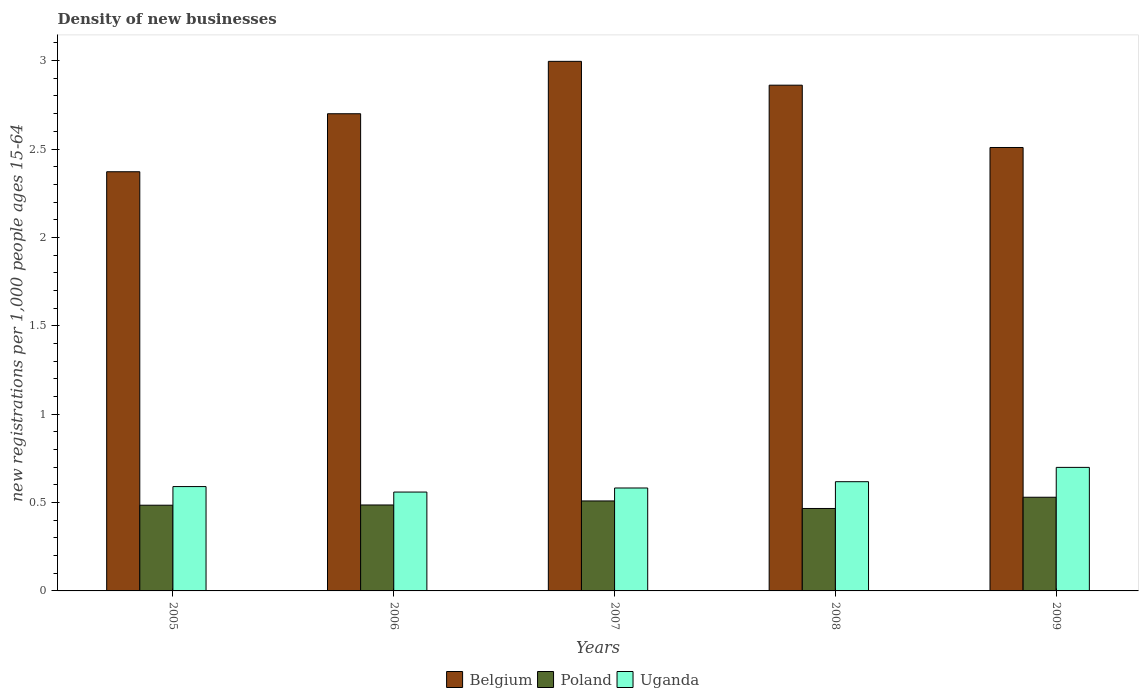How many different coloured bars are there?
Provide a short and direct response. 3. How many groups of bars are there?
Your answer should be compact. 5. What is the number of new registrations in Poland in 2006?
Make the answer very short. 0.49. Across all years, what is the maximum number of new registrations in Poland?
Offer a very short reply. 0.53. Across all years, what is the minimum number of new registrations in Poland?
Offer a terse response. 0.47. In which year was the number of new registrations in Uganda maximum?
Keep it short and to the point. 2009. What is the total number of new registrations in Uganda in the graph?
Provide a succinct answer. 3.05. What is the difference between the number of new registrations in Poland in 2005 and that in 2008?
Provide a short and direct response. 0.02. What is the difference between the number of new registrations in Poland in 2007 and the number of new registrations in Belgium in 2009?
Your answer should be very brief. -2. What is the average number of new registrations in Belgium per year?
Provide a succinct answer. 2.69. In the year 2006, what is the difference between the number of new registrations in Belgium and number of new registrations in Uganda?
Ensure brevity in your answer.  2.14. What is the ratio of the number of new registrations in Uganda in 2006 to that in 2007?
Provide a succinct answer. 0.96. Is the difference between the number of new registrations in Belgium in 2005 and 2006 greater than the difference between the number of new registrations in Uganda in 2005 and 2006?
Make the answer very short. No. What is the difference between the highest and the second highest number of new registrations in Poland?
Make the answer very short. 0.02. What is the difference between the highest and the lowest number of new registrations in Poland?
Make the answer very short. 0.06. Is the sum of the number of new registrations in Poland in 2005 and 2009 greater than the maximum number of new registrations in Uganda across all years?
Your answer should be compact. Yes. What does the 1st bar from the right in 2009 represents?
Your answer should be compact. Uganda. How many years are there in the graph?
Keep it short and to the point. 5. What is the difference between two consecutive major ticks on the Y-axis?
Your answer should be compact. 0.5. Are the values on the major ticks of Y-axis written in scientific E-notation?
Give a very brief answer. No. Does the graph contain any zero values?
Give a very brief answer. No. Does the graph contain grids?
Your response must be concise. No. Where does the legend appear in the graph?
Provide a short and direct response. Bottom center. How many legend labels are there?
Make the answer very short. 3. How are the legend labels stacked?
Your answer should be compact. Horizontal. What is the title of the graph?
Offer a terse response. Density of new businesses. What is the label or title of the X-axis?
Your answer should be compact. Years. What is the label or title of the Y-axis?
Your answer should be compact. New registrations per 1,0 people ages 15-64. What is the new registrations per 1,000 people ages 15-64 in Belgium in 2005?
Provide a short and direct response. 2.37. What is the new registrations per 1,000 people ages 15-64 of Poland in 2005?
Make the answer very short. 0.48. What is the new registrations per 1,000 people ages 15-64 of Uganda in 2005?
Your answer should be very brief. 0.59. What is the new registrations per 1,000 people ages 15-64 in Belgium in 2006?
Make the answer very short. 2.7. What is the new registrations per 1,000 people ages 15-64 of Poland in 2006?
Offer a very short reply. 0.49. What is the new registrations per 1,000 people ages 15-64 in Uganda in 2006?
Ensure brevity in your answer.  0.56. What is the new registrations per 1,000 people ages 15-64 in Belgium in 2007?
Provide a short and direct response. 3. What is the new registrations per 1,000 people ages 15-64 of Poland in 2007?
Provide a succinct answer. 0.51. What is the new registrations per 1,000 people ages 15-64 in Uganda in 2007?
Make the answer very short. 0.58. What is the new registrations per 1,000 people ages 15-64 in Belgium in 2008?
Offer a terse response. 2.86. What is the new registrations per 1,000 people ages 15-64 in Poland in 2008?
Keep it short and to the point. 0.47. What is the new registrations per 1,000 people ages 15-64 in Uganda in 2008?
Your response must be concise. 0.62. What is the new registrations per 1,000 people ages 15-64 of Belgium in 2009?
Your answer should be compact. 2.51. What is the new registrations per 1,000 people ages 15-64 in Poland in 2009?
Your answer should be compact. 0.53. What is the new registrations per 1,000 people ages 15-64 in Uganda in 2009?
Offer a terse response. 0.7. Across all years, what is the maximum new registrations per 1,000 people ages 15-64 of Belgium?
Provide a succinct answer. 3. Across all years, what is the maximum new registrations per 1,000 people ages 15-64 of Poland?
Give a very brief answer. 0.53. Across all years, what is the maximum new registrations per 1,000 people ages 15-64 in Uganda?
Make the answer very short. 0.7. Across all years, what is the minimum new registrations per 1,000 people ages 15-64 in Belgium?
Your answer should be compact. 2.37. Across all years, what is the minimum new registrations per 1,000 people ages 15-64 in Poland?
Ensure brevity in your answer.  0.47. Across all years, what is the minimum new registrations per 1,000 people ages 15-64 in Uganda?
Offer a terse response. 0.56. What is the total new registrations per 1,000 people ages 15-64 in Belgium in the graph?
Make the answer very short. 13.44. What is the total new registrations per 1,000 people ages 15-64 in Poland in the graph?
Offer a very short reply. 2.48. What is the total new registrations per 1,000 people ages 15-64 in Uganda in the graph?
Your answer should be very brief. 3.05. What is the difference between the new registrations per 1,000 people ages 15-64 of Belgium in 2005 and that in 2006?
Offer a very short reply. -0.33. What is the difference between the new registrations per 1,000 people ages 15-64 in Poland in 2005 and that in 2006?
Provide a short and direct response. -0. What is the difference between the new registrations per 1,000 people ages 15-64 in Uganda in 2005 and that in 2006?
Your answer should be very brief. 0.03. What is the difference between the new registrations per 1,000 people ages 15-64 in Belgium in 2005 and that in 2007?
Ensure brevity in your answer.  -0.62. What is the difference between the new registrations per 1,000 people ages 15-64 of Poland in 2005 and that in 2007?
Provide a succinct answer. -0.02. What is the difference between the new registrations per 1,000 people ages 15-64 in Uganda in 2005 and that in 2007?
Give a very brief answer. 0.01. What is the difference between the new registrations per 1,000 people ages 15-64 of Belgium in 2005 and that in 2008?
Offer a terse response. -0.49. What is the difference between the new registrations per 1,000 people ages 15-64 of Poland in 2005 and that in 2008?
Your answer should be very brief. 0.02. What is the difference between the new registrations per 1,000 people ages 15-64 in Uganda in 2005 and that in 2008?
Make the answer very short. -0.03. What is the difference between the new registrations per 1,000 people ages 15-64 of Belgium in 2005 and that in 2009?
Ensure brevity in your answer.  -0.14. What is the difference between the new registrations per 1,000 people ages 15-64 of Poland in 2005 and that in 2009?
Provide a short and direct response. -0.05. What is the difference between the new registrations per 1,000 people ages 15-64 of Uganda in 2005 and that in 2009?
Your answer should be compact. -0.11. What is the difference between the new registrations per 1,000 people ages 15-64 of Belgium in 2006 and that in 2007?
Offer a terse response. -0.3. What is the difference between the new registrations per 1,000 people ages 15-64 in Poland in 2006 and that in 2007?
Ensure brevity in your answer.  -0.02. What is the difference between the new registrations per 1,000 people ages 15-64 in Uganda in 2006 and that in 2007?
Make the answer very short. -0.02. What is the difference between the new registrations per 1,000 people ages 15-64 of Belgium in 2006 and that in 2008?
Your response must be concise. -0.16. What is the difference between the new registrations per 1,000 people ages 15-64 of Poland in 2006 and that in 2008?
Provide a succinct answer. 0.02. What is the difference between the new registrations per 1,000 people ages 15-64 in Uganda in 2006 and that in 2008?
Make the answer very short. -0.06. What is the difference between the new registrations per 1,000 people ages 15-64 in Belgium in 2006 and that in 2009?
Ensure brevity in your answer.  0.19. What is the difference between the new registrations per 1,000 people ages 15-64 of Poland in 2006 and that in 2009?
Ensure brevity in your answer.  -0.04. What is the difference between the new registrations per 1,000 people ages 15-64 in Uganda in 2006 and that in 2009?
Make the answer very short. -0.14. What is the difference between the new registrations per 1,000 people ages 15-64 in Belgium in 2007 and that in 2008?
Your answer should be very brief. 0.13. What is the difference between the new registrations per 1,000 people ages 15-64 in Poland in 2007 and that in 2008?
Your answer should be very brief. 0.04. What is the difference between the new registrations per 1,000 people ages 15-64 of Uganda in 2007 and that in 2008?
Your answer should be compact. -0.04. What is the difference between the new registrations per 1,000 people ages 15-64 in Belgium in 2007 and that in 2009?
Provide a short and direct response. 0.49. What is the difference between the new registrations per 1,000 people ages 15-64 of Poland in 2007 and that in 2009?
Your response must be concise. -0.02. What is the difference between the new registrations per 1,000 people ages 15-64 of Uganda in 2007 and that in 2009?
Provide a succinct answer. -0.12. What is the difference between the new registrations per 1,000 people ages 15-64 of Belgium in 2008 and that in 2009?
Provide a succinct answer. 0.35. What is the difference between the new registrations per 1,000 people ages 15-64 of Poland in 2008 and that in 2009?
Ensure brevity in your answer.  -0.06. What is the difference between the new registrations per 1,000 people ages 15-64 of Uganda in 2008 and that in 2009?
Your response must be concise. -0.08. What is the difference between the new registrations per 1,000 people ages 15-64 of Belgium in 2005 and the new registrations per 1,000 people ages 15-64 of Poland in 2006?
Your answer should be very brief. 1.89. What is the difference between the new registrations per 1,000 people ages 15-64 of Belgium in 2005 and the new registrations per 1,000 people ages 15-64 of Uganda in 2006?
Your answer should be compact. 1.81. What is the difference between the new registrations per 1,000 people ages 15-64 in Poland in 2005 and the new registrations per 1,000 people ages 15-64 in Uganda in 2006?
Provide a succinct answer. -0.07. What is the difference between the new registrations per 1,000 people ages 15-64 in Belgium in 2005 and the new registrations per 1,000 people ages 15-64 in Poland in 2007?
Provide a succinct answer. 1.86. What is the difference between the new registrations per 1,000 people ages 15-64 in Belgium in 2005 and the new registrations per 1,000 people ages 15-64 in Uganda in 2007?
Your answer should be very brief. 1.79. What is the difference between the new registrations per 1,000 people ages 15-64 of Poland in 2005 and the new registrations per 1,000 people ages 15-64 of Uganda in 2007?
Ensure brevity in your answer.  -0.1. What is the difference between the new registrations per 1,000 people ages 15-64 in Belgium in 2005 and the new registrations per 1,000 people ages 15-64 in Poland in 2008?
Your response must be concise. 1.91. What is the difference between the new registrations per 1,000 people ages 15-64 in Belgium in 2005 and the new registrations per 1,000 people ages 15-64 in Uganda in 2008?
Give a very brief answer. 1.75. What is the difference between the new registrations per 1,000 people ages 15-64 in Poland in 2005 and the new registrations per 1,000 people ages 15-64 in Uganda in 2008?
Your answer should be compact. -0.13. What is the difference between the new registrations per 1,000 people ages 15-64 in Belgium in 2005 and the new registrations per 1,000 people ages 15-64 in Poland in 2009?
Offer a very short reply. 1.84. What is the difference between the new registrations per 1,000 people ages 15-64 in Belgium in 2005 and the new registrations per 1,000 people ages 15-64 in Uganda in 2009?
Provide a short and direct response. 1.67. What is the difference between the new registrations per 1,000 people ages 15-64 in Poland in 2005 and the new registrations per 1,000 people ages 15-64 in Uganda in 2009?
Offer a very short reply. -0.21. What is the difference between the new registrations per 1,000 people ages 15-64 of Belgium in 2006 and the new registrations per 1,000 people ages 15-64 of Poland in 2007?
Your answer should be very brief. 2.19. What is the difference between the new registrations per 1,000 people ages 15-64 in Belgium in 2006 and the new registrations per 1,000 people ages 15-64 in Uganda in 2007?
Your response must be concise. 2.12. What is the difference between the new registrations per 1,000 people ages 15-64 of Poland in 2006 and the new registrations per 1,000 people ages 15-64 of Uganda in 2007?
Provide a short and direct response. -0.1. What is the difference between the new registrations per 1,000 people ages 15-64 of Belgium in 2006 and the new registrations per 1,000 people ages 15-64 of Poland in 2008?
Provide a succinct answer. 2.23. What is the difference between the new registrations per 1,000 people ages 15-64 of Belgium in 2006 and the new registrations per 1,000 people ages 15-64 of Uganda in 2008?
Offer a very short reply. 2.08. What is the difference between the new registrations per 1,000 people ages 15-64 in Poland in 2006 and the new registrations per 1,000 people ages 15-64 in Uganda in 2008?
Your response must be concise. -0.13. What is the difference between the new registrations per 1,000 people ages 15-64 of Belgium in 2006 and the new registrations per 1,000 people ages 15-64 of Poland in 2009?
Keep it short and to the point. 2.17. What is the difference between the new registrations per 1,000 people ages 15-64 of Belgium in 2006 and the new registrations per 1,000 people ages 15-64 of Uganda in 2009?
Provide a succinct answer. 2. What is the difference between the new registrations per 1,000 people ages 15-64 in Poland in 2006 and the new registrations per 1,000 people ages 15-64 in Uganda in 2009?
Give a very brief answer. -0.21. What is the difference between the new registrations per 1,000 people ages 15-64 in Belgium in 2007 and the new registrations per 1,000 people ages 15-64 in Poland in 2008?
Give a very brief answer. 2.53. What is the difference between the new registrations per 1,000 people ages 15-64 in Belgium in 2007 and the new registrations per 1,000 people ages 15-64 in Uganda in 2008?
Your response must be concise. 2.38. What is the difference between the new registrations per 1,000 people ages 15-64 in Poland in 2007 and the new registrations per 1,000 people ages 15-64 in Uganda in 2008?
Make the answer very short. -0.11. What is the difference between the new registrations per 1,000 people ages 15-64 in Belgium in 2007 and the new registrations per 1,000 people ages 15-64 in Poland in 2009?
Provide a short and direct response. 2.47. What is the difference between the new registrations per 1,000 people ages 15-64 in Belgium in 2007 and the new registrations per 1,000 people ages 15-64 in Uganda in 2009?
Offer a terse response. 2.3. What is the difference between the new registrations per 1,000 people ages 15-64 of Poland in 2007 and the new registrations per 1,000 people ages 15-64 of Uganda in 2009?
Keep it short and to the point. -0.19. What is the difference between the new registrations per 1,000 people ages 15-64 in Belgium in 2008 and the new registrations per 1,000 people ages 15-64 in Poland in 2009?
Provide a succinct answer. 2.33. What is the difference between the new registrations per 1,000 people ages 15-64 in Belgium in 2008 and the new registrations per 1,000 people ages 15-64 in Uganda in 2009?
Give a very brief answer. 2.16. What is the difference between the new registrations per 1,000 people ages 15-64 in Poland in 2008 and the new registrations per 1,000 people ages 15-64 in Uganda in 2009?
Your response must be concise. -0.23. What is the average new registrations per 1,000 people ages 15-64 in Belgium per year?
Provide a short and direct response. 2.69. What is the average new registrations per 1,000 people ages 15-64 in Poland per year?
Your answer should be compact. 0.5. What is the average new registrations per 1,000 people ages 15-64 of Uganda per year?
Give a very brief answer. 0.61. In the year 2005, what is the difference between the new registrations per 1,000 people ages 15-64 in Belgium and new registrations per 1,000 people ages 15-64 in Poland?
Your response must be concise. 1.89. In the year 2005, what is the difference between the new registrations per 1,000 people ages 15-64 in Belgium and new registrations per 1,000 people ages 15-64 in Uganda?
Your answer should be compact. 1.78. In the year 2005, what is the difference between the new registrations per 1,000 people ages 15-64 in Poland and new registrations per 1,000 people ages 15-64 in Uganda?
Your response must be concise. -0.11. In the year 2006, what is the difference between the new registrations per 1,000 people ages 15-64 in Belgium and new registrations per 1,000 people ages 15-64 in Poland?
Your answer should be compact. 2.21. In the year 2006, what is the difference between the new registrations per 1,000 people ages 15-64 of Belgium and new registrations per 1,000 people ages 15-64 of Uganda?
Make the answer very short. 2.14. In the year 2006, what is the difference between the new registrations per 1,000 people ages 15-64 in Poland and new registrations per 1,000 people ages 15-64 in Uganda?
Your answer should be very brief. -0.07. In the year 2007, what is the difference between the new registrations per 1,000 people ages 15-64 of Belgium and new registrations per 1,000 people ages 15-64 of Poland?
Offer a terse response. 2.49. In the year 2007, what is the difference between the new registrations per 1,000 people ages 15-64 in Belgium and new registrations per 1,000 people ages 15-64 in Uganda?
Keep it short and to the point. 2.41. In the year 2007, what is the difference between the new registrations per 1,000 people ages 15-64 of Poland and new registrations per 1,000 people ages 15-64 of Uganda?
Provide a succinct answer. -0.07. In the year 2008, what is the difference between the new registrations per 1,000 people ages 15-64 of Belgium and new registrations per 1,000 people ages 15-64 of Poland?
Ensure brevity in your answer.  2.39. In the year 2008, what is the difference between the new registrations per 1,000 people ages 15-64 of Belgium and new registrations per 1,000 people ages 15-64 of Uganda?
Offer a terse response. 2.24. In the year 2008, what is the difference between the new registrations per 1,000 people ages 15-64 of Poland and new registrations per 1,000 people ages 15-64 of Uganda?
Offer a very short reply. -0.15. In the year 2009, what is the difference between the new registrations per 1,000 people ages 15-64 in Belgium and new registrations per 1,000 people ages 15-64 in Poland?
Provide a succinct answer. 1.98. In the year 2009, what is the difference between the new registrations per 1,000 people ages 15-64 of Belgium and new registrations per 1,000 people ages 15-64 of Uganda?
Your answer should be very brief. 1.81. In the year 2009, what is the difference between the new registrations per 1,000 people ages 15-64 of Poland and new registrations per 1,000 people ages 15-64 of Uganda?
Provide a short and direct response. -0.17. What is the ratio of the new registrations per 1,000 people ages 15-64 in Belgium in 2005 to that in 2006?
Give a very brief answer. 0.88. What is the ratio of the new registrations per 1,000 people ages 15-64 of Poland in 2005 to that in 2006?
Keep it short and to the point. 1. What is the ratio of the new registrations per 1,000 people ages 15-64 in Uganda in 2005 to that in 2006?
Your response must be concise. 1.06. What is the ratio of the new registrations per 1,000 people ages 15-64 of Belgium in 2005 to that in 2007?
Your answer should be compact. 0.79. What is the ratio of the new registrations per 1,000 people ages 15-64 of Poland in 2005 to that in 2007?
Offer a terse response. 0.95. What is the ratio of the new registrations per 1,000 people ages 15-64 in Uganda in 2005 to that in 2007?
Your response must be concise. 1.01. What is the ratio of the new registrations per 1,000 people ages 15-64 of Belgium in 2005 to that in 2008?
Your answer should be very brief. 0.83. What is the ratio of the new registrations per 1,000 people ages 15-64 in Poland in 2005 to that in 2008?
Your answer should be very brief. 1.04. What is the ratio of the new registrations per 1,000 people ages 15-64 in Uganda in 2005 to that in 2008?
Keep it short and to the point. 0.96. What is the ratio of the new registrations per 1,000 people ages 15-64 of Belgium in 2005 to that in 2009?
Make the answer very short. 0.95. What is the ratio of the new registrations per 1,000 people ages 15-64 in Poland in 2005 to that in 2009?
Your answer should be compact. 0.92. What is the ratio of the new registrations per 1,000 people ages 15-64 of Uganda in 2005 to that in 2009?
Keep it short and to the point. 0.84. What is the ratio of the new registrations per 1,000 people ages 15-64 in Belgium in 2006 to that in 2007?
Your answer should be compact. 0.9. What is the ratio of the new registrations per 1,000 people ages 15-64 of Poland in 2006 to that in 2007?
Give a very brief answer. 0.96. What is the ratio of the new registrations per 1,000 people ages 15-64 of Uganda in 2006 to that in 2007?
Your answer should be very brief. 0.96. What is the ratio of the new registrations per 1,000 people ages 15-64 in Belgium in 2006 to that in 2008?
Keep it short and to the point. 0.94. What is the ratio of the new registrations per 1,000 people ages 15-64 in Poland in 2006 to that in 2008?
Your answer should be compact. 1.04. What is the ratio of the new registrations per 1,000 people ages 15-64 in Uganda in 2006 to that in 2008?
Provide a succinct answer. 0.91. What is the ratio of the new registrations per 1,000 people ages 15-64 of Belgium in 2006 to that in 2009?
Provide a short and direct response. 1.08. What is the ratio of the new registrations per 1,000 people ages 15-64 of Poland in 2006 to that in 2009?
Offer a very short reply. 0.92. What is the ratio of the new registrations per 1,000 people ages 15-64 of Uganda in 2006 to that in 2009?
Offer a terse response. 0.8. What is the ratio of the new registrations per 1,000 people ages 15-64 of Belgium in 2007 to that in 2008?
Your response must be concise. 1.05. What is the ratio of the new registrations per 1,000 people ages 15-64 in Poland in 2007 to that in 2008?
Your answer should be compact. 1.09. What is the ratio of the new registrations per 1,000 people ages 15-64 of Uganda in 2007 to that in 2008?
Offer a terse response. 0.94. What is the ratio of the new registrations per 1,000 people ages 15-64 in Belgium in 2007 to that in 2009?
Your response must be concise. 1.19. What is the ratio of the new registrations per 1,000 people ages 15-64 of Poland in 2007 to that in 2009?
Your answer should be compact. 0.96. What is the ratio of the new registrations per 1,000 people ages 15-64 of Uganda in 2007 to that in 2009?
Provide a succinct answer. 0.83. What is the ratio of the new registrations per 1,000 people ages 15-64 of Belgium in 2008 to that in 2009?
Give a very brief answer. 1.14. What is the ratio of the new registrations per 1,000 people ages 15-64 of Poland in 2008 to that in 2009?
Make the answer very short. 0.88. What is the ratio of the new registrations per 1,000 people ages 15-64 in Uganda in 2008 to that in 2009?
Your response must be concise. 0.88. What is the difference between the highest and the second highest new registrations per 1,000 people ages 15-64 of Belgium?
Offer a very short reply. 0.13. What is the difference between the highest and the second highest new registrations per 1,000 people ages 15-64 of Poland?
Your answer should be compact. 0.02. What is the difference between the highest and the second highest new registrations per 1,000 people ages 15-64 in Uganda?
Offer a very short reply. 0.08. What is the difference between the highest and the lowest new registrations per 1,000 people ages 15-64 of Belgium?
Offer a terse response. 0.62. What is the difference between the highest and the lowest new registrations per 1,000 people ages 15-64 in Poland?
Keep it short and to the point. 0.06. What is the difference between the highest and the lowest new registrations per 1,000 people ages 15-64 of Uganda?
Offer a very short reply. 0.14. 